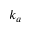Convert formula to latex. <formula><loc_0><loc_0><loc_500><loc_500>k _ { a }</formula> 